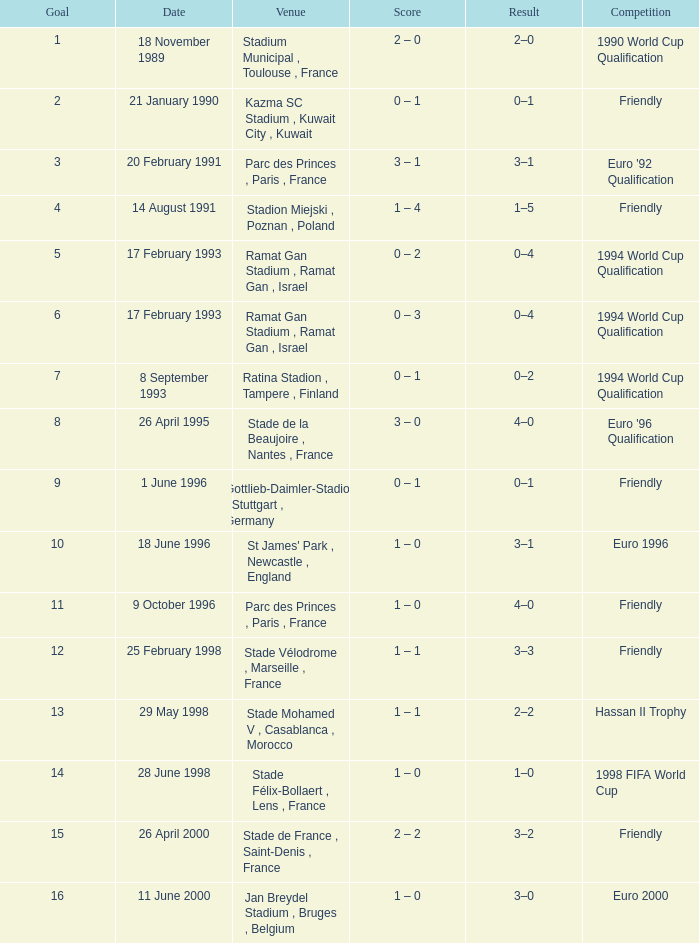What was the date of the game with a goal of 7? 8 September 1993. 